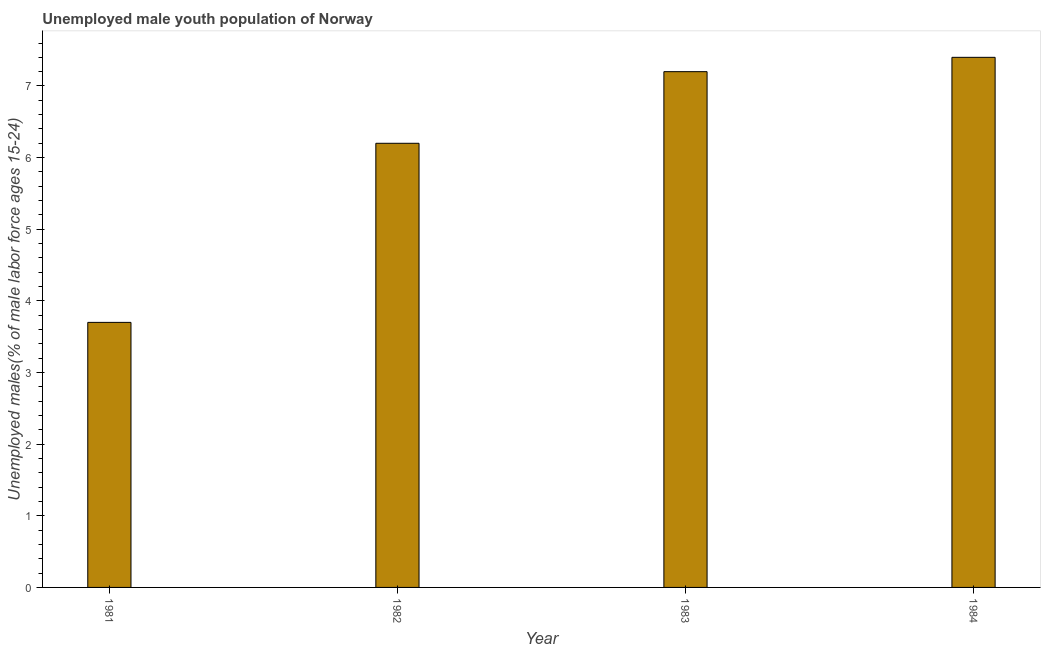Does the graph contain grids?
Your answer should be very brief. No. What is the title of the graph?
Give a very brief answer. Unemployed male youth population of Norway. What is the label or title of the Y-axis?
Ensure brevity in your answer.  Unemployed males(% of male labor force ages 15-24). What is the unemployed male youth in 1982?
Ensure brevity in your answer.  6.2. Across all years, what is the maximum unemployed male youth?
Offer a very short reply. 7.4. Across all years, what is the minimum unemployed male youth?
Provide a short and direct response. 3.7. What is the sum of the unemployed male youth?
Your answer should be compact. 24.5. What is the average unemployed male youth per year?
Your answer should be very brief. 6.12. What is the median unemployed male youth?
Keep it short and to the point. 6.7. In how many years, is the unemployed male youth greater than 3.4 %?
Make the answer very short. 4. Do a majority of the years between 1984 and 1983 (inclusive) have unemployed male youth greater than 4.6 %?
Make the answer very short. No. What is the ratio of the unemployed male youth in 1981 to that in 1982?
Your response must be concise. 0.6. Is the difference between the unemployed male youth in 1982 and 1984 greater than the difference between any two years?
Provide a succinct answer. No. What is the difference between the highest and the second highest unemployed male youth?
Make the answer very short. 0.2. How many bars are there?
Your response must be concise. 4. How many years are there in the graph?
Provide a succinct answer. 4. What is the Unemployed males(% of male labor force ages 15-24) of 1981?
Offer a terse response. 3.7. What is the Unemployed males(% of male labor force ages 15-24) of 1982?
Ensure brevity in your answer.  6.2. What is the Unemployed males(% of male labor force ages 15-24) of 1983?
Make the answer very short. 7.2. What is the Unemployed males(% of male labor force ages 15-24) in 1984?
Your answer should be very brief. 7.4. What is the difference between the Unemployed males(% of male labor force ages 15-24) in 1981 and 1984?
Keep it short and to the point. -3.7. What is the difference between the Unemployed males(% of male labor force ages 15-24) in 1982 and 1983?
Keep it short and to the point. -1. What is the ratio of the Unemployed males(% of male labor force ages 15-24) in 1981 to that in 1982?
Make the answer very short. 0.6. What is the ratio of the Unemployed males(% of male labor force ages 15-24) in 1981 to that in 1983?
Your response must be concise. 0.51. What is the ratio of the Unemployed males(% of male labor force ages 15-24) in 1982 to that in 1983?
Your answer should be very brief. 0.86. What is the ratio of the Unemployed males(% of male labor force ages 15-24) in 1982 to that in 1984?
Offer a terse response. 0.84. What is the ratio of the Unemployed males(% of male labor force ages 15-24) in 1983 to that in 1984?
Provide a short and direct response. 0.97. 